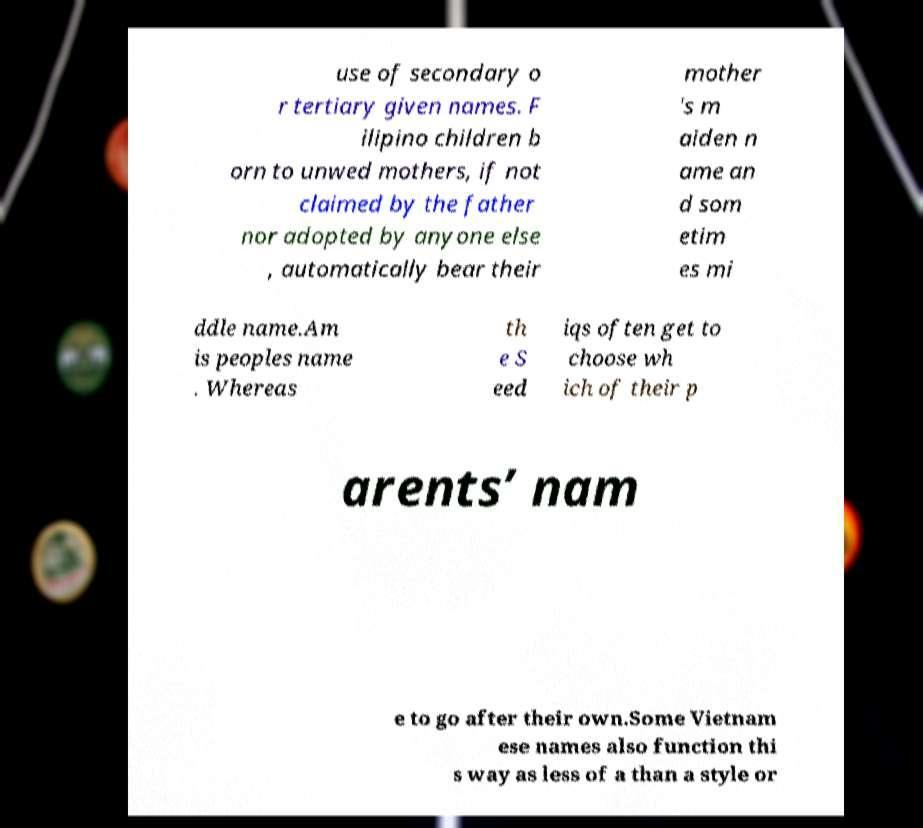Could you extract and type out the text from this image? use of secondary o r tertiary given names. F ilipino children b orn to unwed mothers, if not claimed by the father nor adopted by anyone else , automatically bear their mother 's m aiden n ame an d som etim es mi ddle name.Am is peoples name . Whereas th e S eed iqs often get to choose wh ich of their p arents’ nam e to go after their own.Some Vietnam ese names also function thi s way as less of a than a style or 